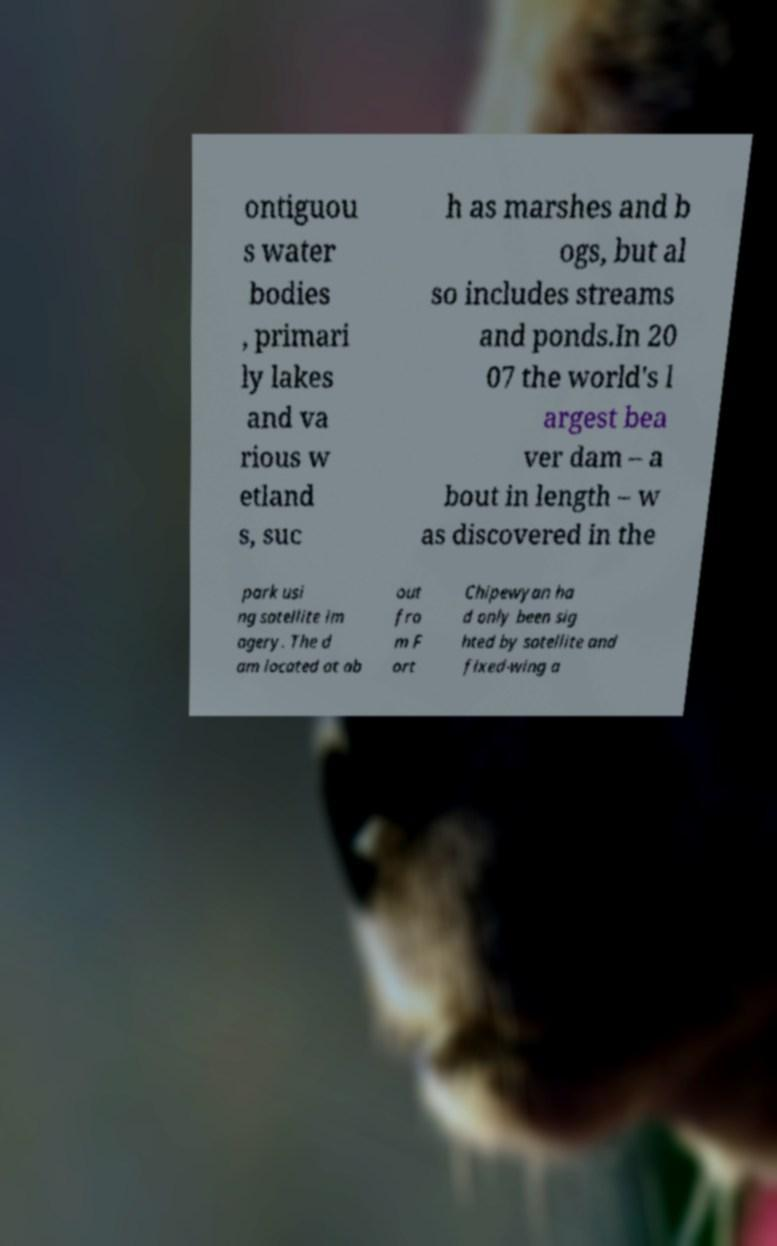Can you read and provide the text displayed in the image?This photo seems to have some interesting text. Can you extract and type it out for me? ontiguou s water bodies , primari ly lakes and va rious w etland s, suc h as marshes and b ogs, but al so includes streams and ponds.In 20 07 the world's l argest bea ver dam – a bout in length – w as discovered in the park usi ng satellite im agery. The d am located at ab out fro m F ort Chipewyan ha d only been sig hted by satellite and fixed-wing a 